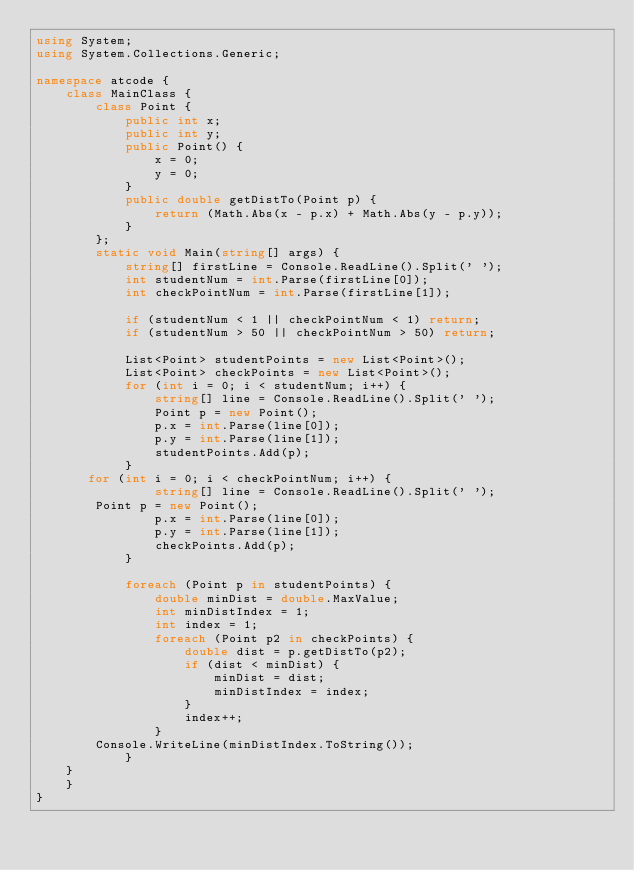Convert code to text. <code><loc_0><loc_0><loc_500><loc_500><_C#_>using System;
using System.Collections.Generic;

namespace atcode {
    class MainClass {
        class Point {
            public int x;
            public int y;
            public Point() {
                x = 0;
                y = 0;
            }
            public double getDistTo(Point p) {
                return (Math.Abs(x - p.x) + Math.Abs(y - p.y));
            }
        };
		static void Main(string[] args) {
            string[] firstLine = Console.ReadLine().Split(' ');
            int studentNum = int.Parse(firstLine[0]);
            int checkPointNum = int.Parse(firstLine[1]);

            if (studentNum < 1 || checkPointNum < 1) return;
            if (studentNum > 50 || checkPointNum > 50) return;

            List<Point> studentPoints = new List<Point>();
            List<Point> checkPoints = new List<Point>();
            for (int i = 0; i < studentNum; i++) {
                string[] line = Console.ReadLine().Split(' ');
                Point p = new Point();
                p.x = int.Parse(line[0]);
                p.y = int.Parse(line[1]);
                studentPoints.Add(p);
            }
	   for (int i = 0; i < checkPointNum; i++) {
                string[] line = Console.ReadLine().Split(' ');
		Point p = new Point();
                p.x = int.Parse(line[0]);
                p.y = int.Parse(line[1]);
                checkPoints.Add(p);
            }

            foreach (Point p in studentPoints) {
                double minDist = double.MaxValue;
                int minDistIndex = 1;
                int index = 1;
                foreach (Point p2 in checkPoints) {
                    double dist = p.getDistTo(p2);
                    if (dist < minDist) {
                        minDist = dist;
                        minDistIndex = index;
                    }
                    index++;
                }
		Console.WriteLine(minDistIndex.ToString());
            }
	}
    }
}
</code> 